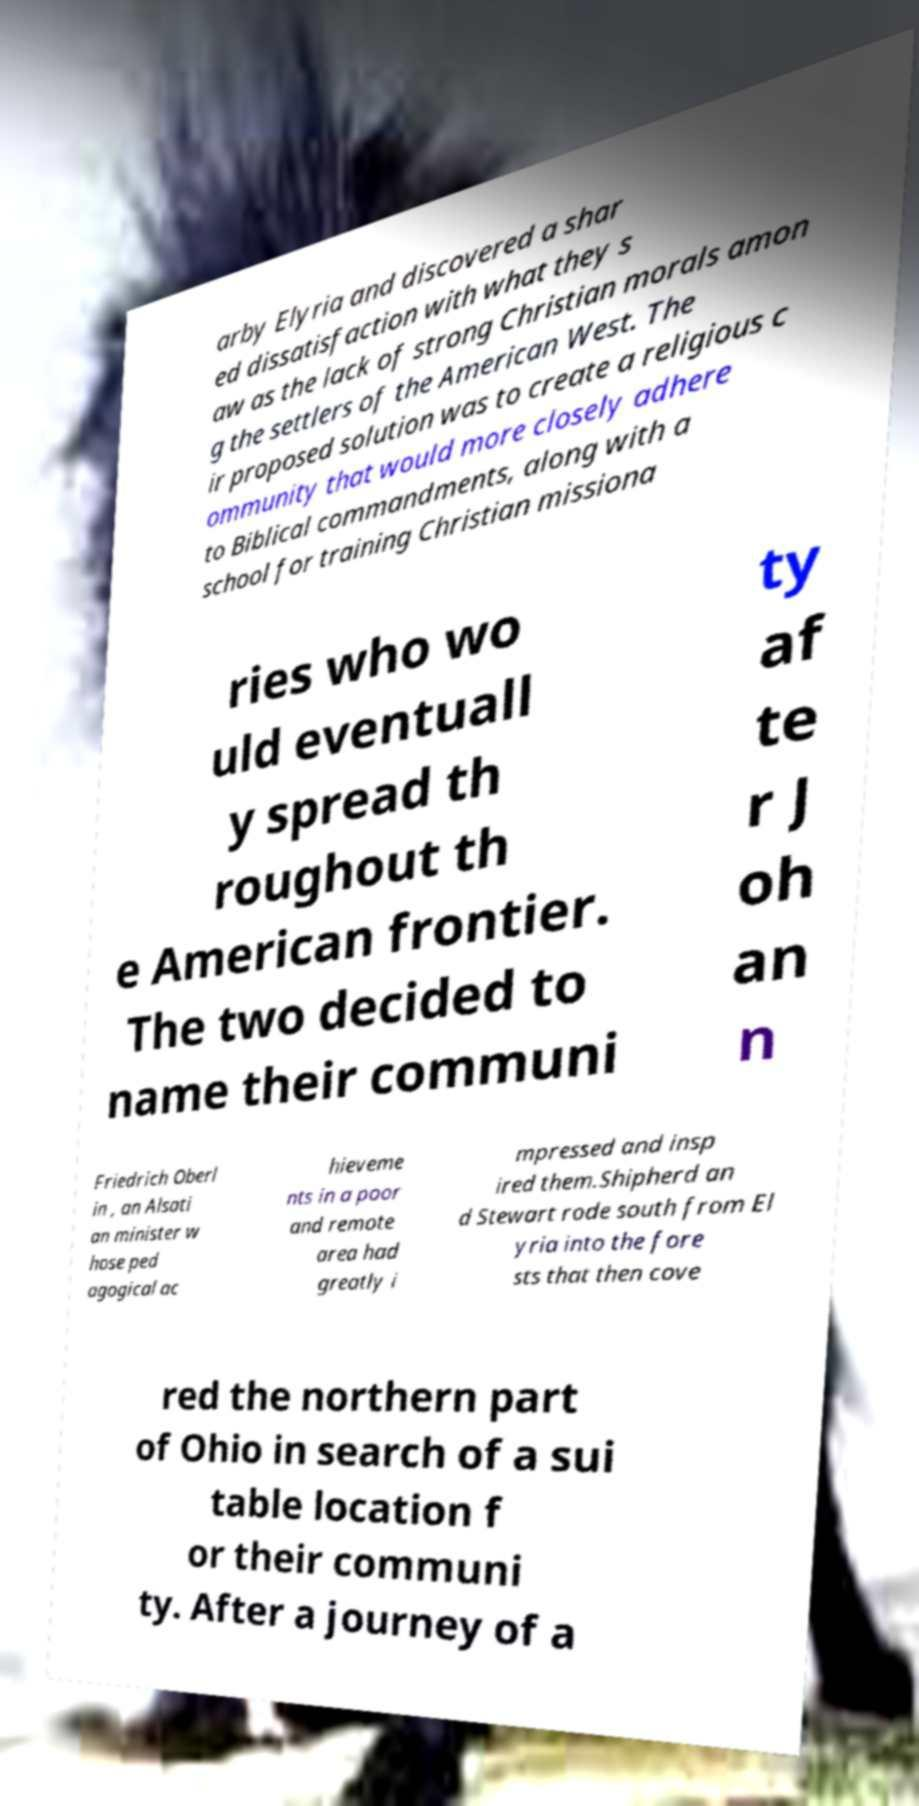Can you read and provide the text displayed in the image?This photo seems to have some interesting text. Can you extract and type it out for me? arby Elyria and discovered a shar ed dissatisfaction with what they s aw as the lack of strong Christian morals amon g the settlers of the American West. The ir proposed solution was to create a religious c ommunity that would more closely adhere to Biblical commandments, along with a school for training Christian missiona ries who wo uld eventuall y spread th roughout th e American frontier. The two decided to name their communi ty af te r J oh an n Friedrich Oberl in , an Alsati an minister w hose ped agogical ac hieveme nts in a poor and remote area had greatly i mpressed and insp ired them.Shipherd an d Stewart rode south from El yria into the fore sts that then cove red the northern part of Ohio in search of a sui table location f or their communi ty. After a journey of a 